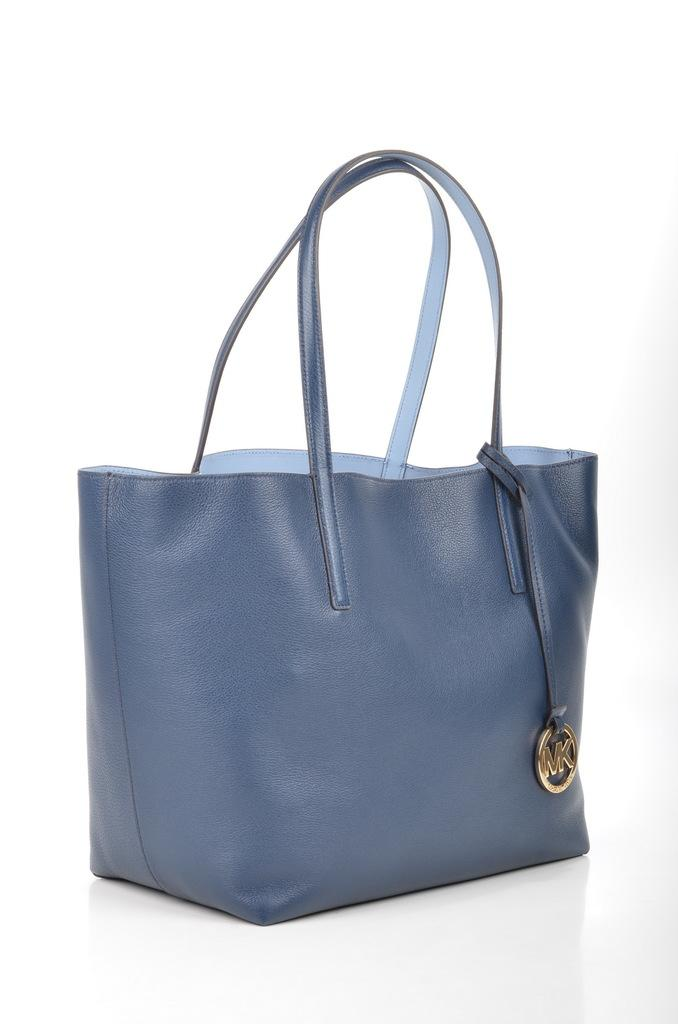What type of accessory is visible in the image? There is a woman's handbag in the image. What is attached to the handbag? There is a ring-type hanging on the bag. Where is the pocket located in the image? There is no pocket mentioned or visible in the image. Can you see any boats in the harbor in the image? There is no harbor or boats present in the image. 